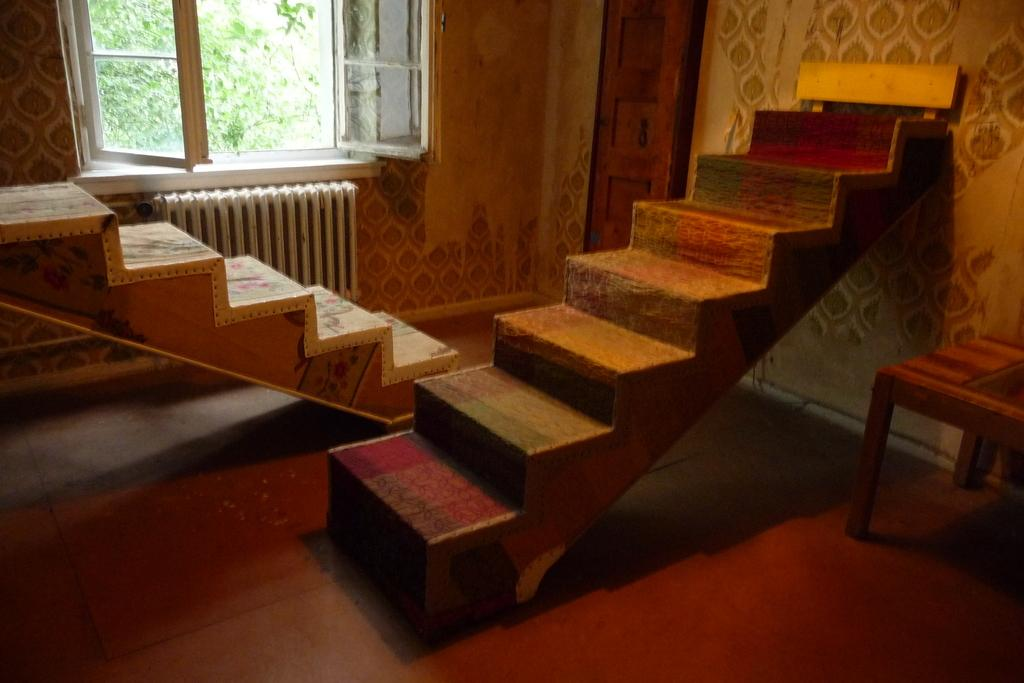What type of structure is present in the image? There are stairs in the image. What can be seen behind the stairs? There is a window, a wall, a door, and a tree visible behind the stairs. What is on the right side of the image? There is a wall and a table on the right side of the image. What type of question is being asked in the image? There is no question being asked in the image; it is a visual representation of stairs, a window, a wall, a door, a tree, and a table. Can you see an arch in the image? There is no arch present in the image. 